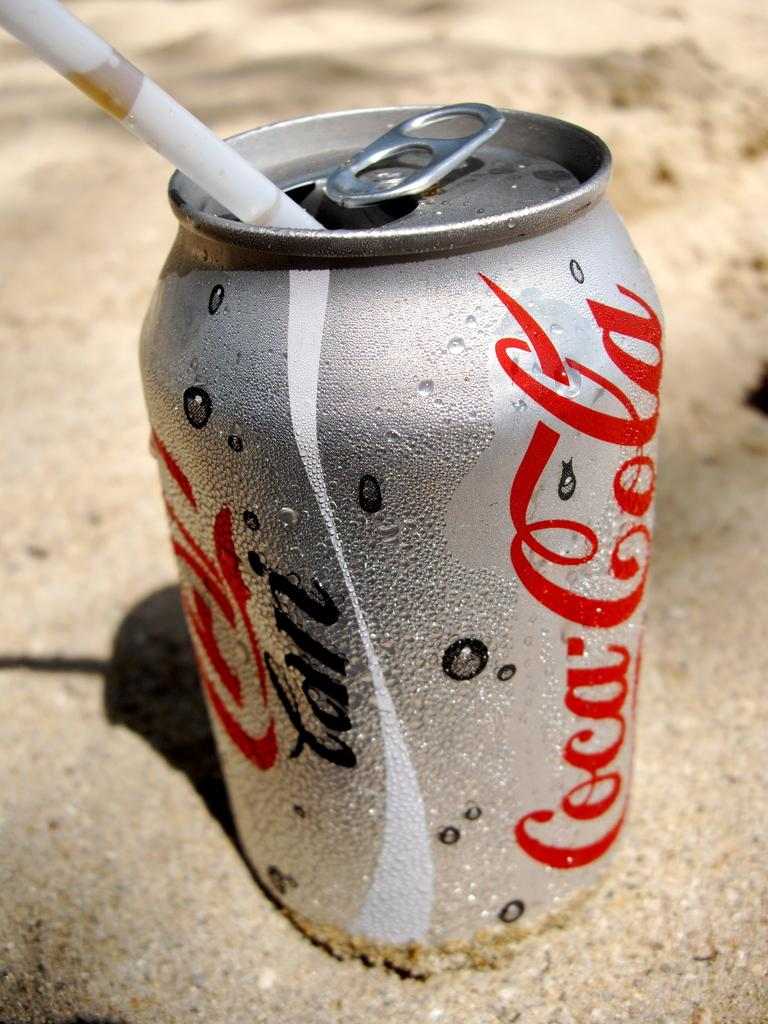Provide a one-sentence caption for the provided image. A coca cola can with a straw in it is sitting on the sand. 